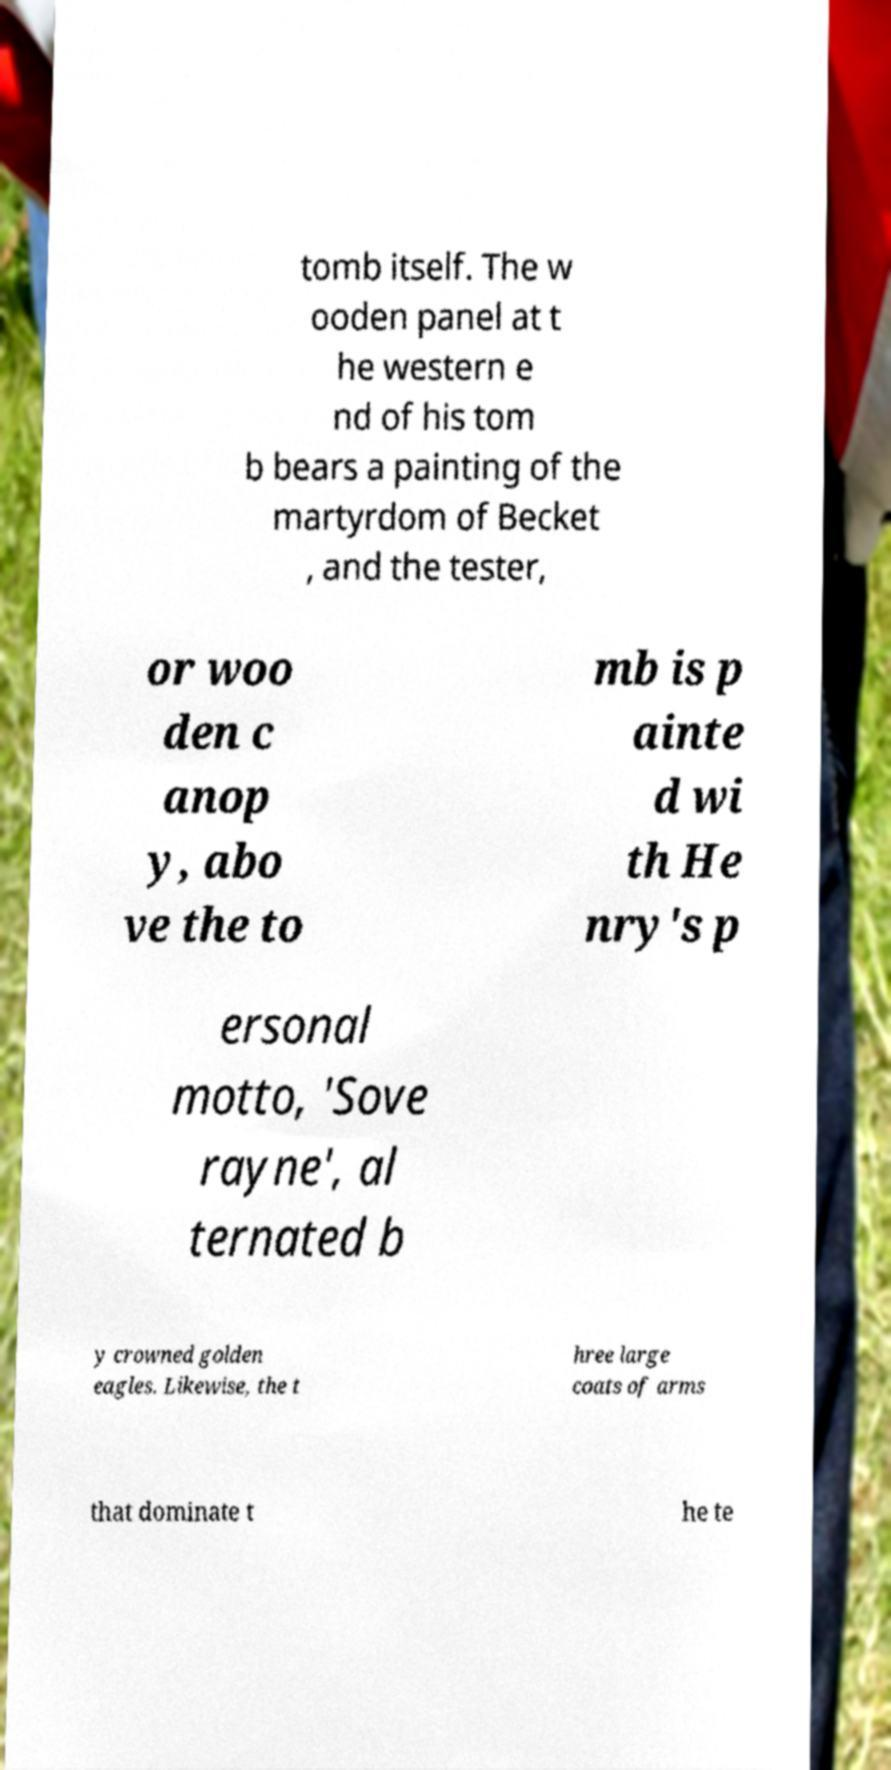For documentation purposes, I need the text within this image transcribed. Could you provide that? tomb itself. The w ooden panel at t he western e nd of his tom b bears a painting of the martyrdom of Becket , and the tester, or woo den c anop y, abo ve the to mb is p ainte d wi th He nry's p ersonal motto, 'Sove rayne', al ternated b y crowned golden eagles. Likewise, the t hree large coats of arms that dominate t he te 